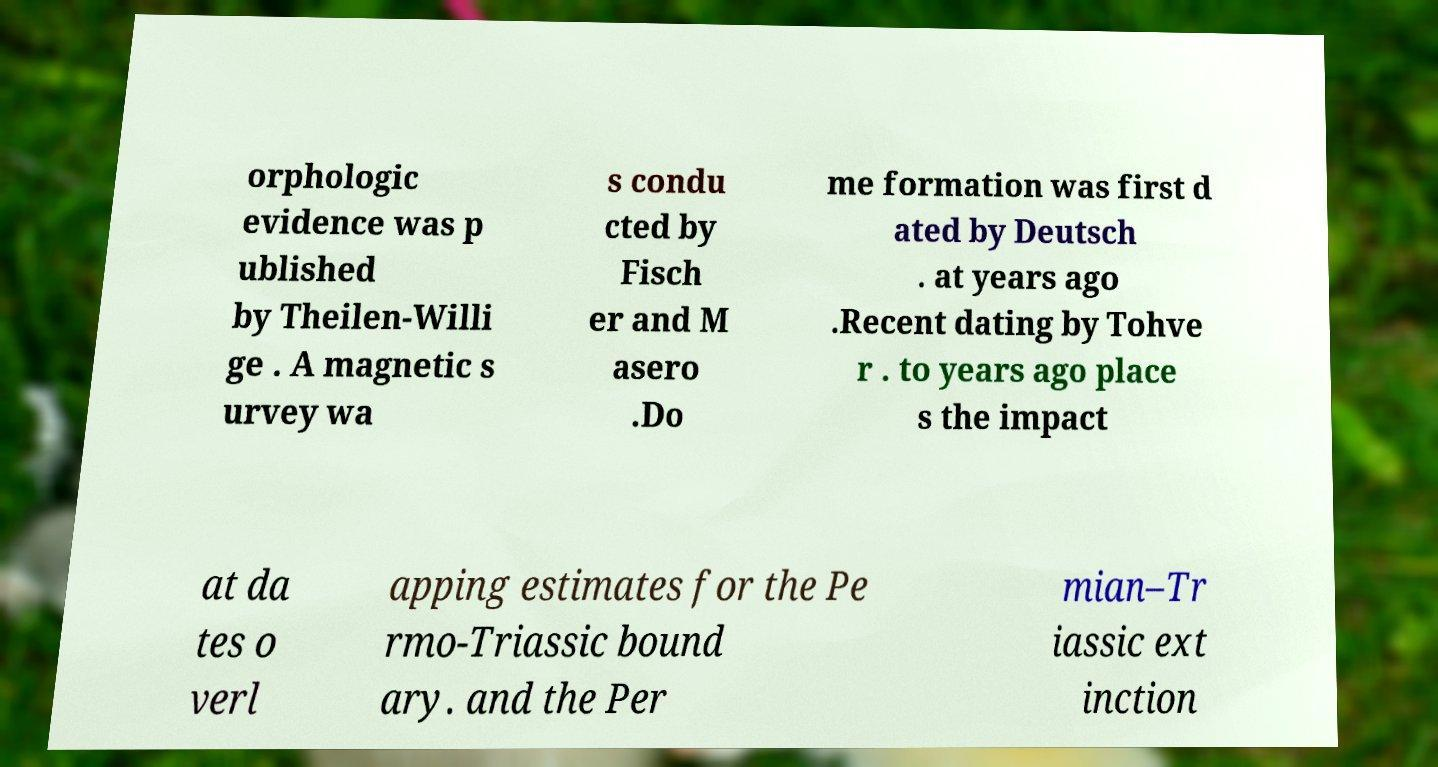Please identify and transcribe the text found in this image. orphologic evidence was p ublished by Theilen-Willi ge . A magnetic s urvey wa s condu cted by Fisch er and M asero .Do me formation was first d ated by Deutsch . at years ago .Recent dating by Tohve r . to years ago place s the impact at da tes o verl apping estimates for the Pe rmo-Triassic bound ary. and the Per mian–Tr iassic ext inction 